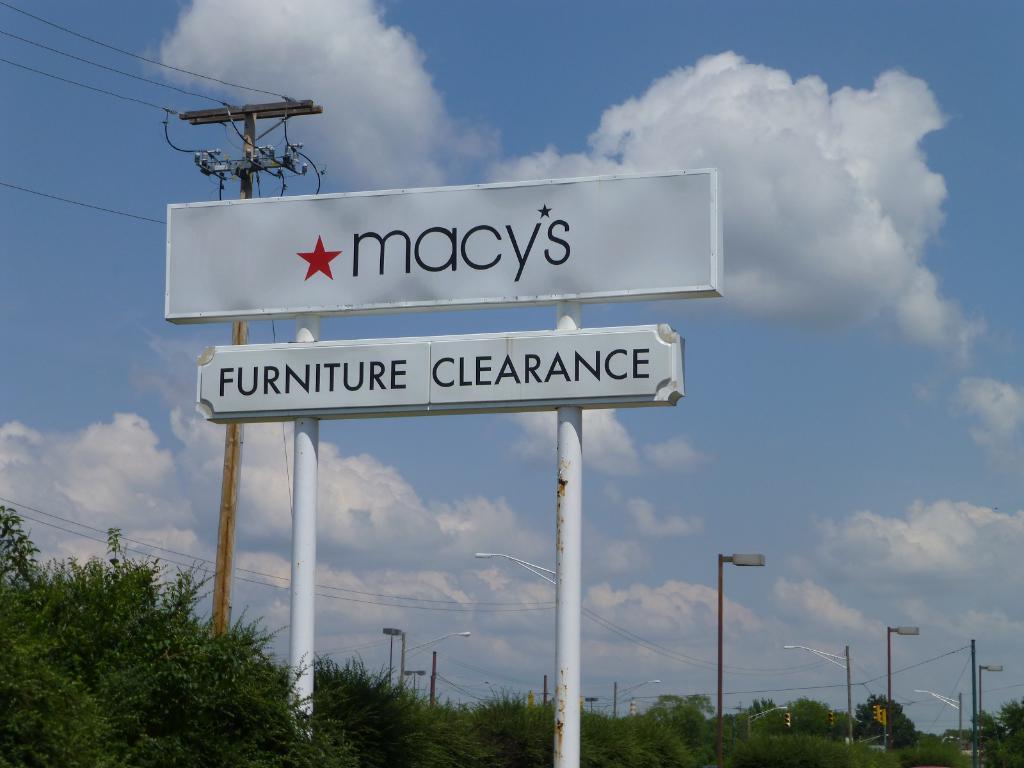What is the name of the store on the top sign?
Provide a succinct answer. Macy's. What type of clearance is being advertised?
Keep it short and to the point. Furniture. 